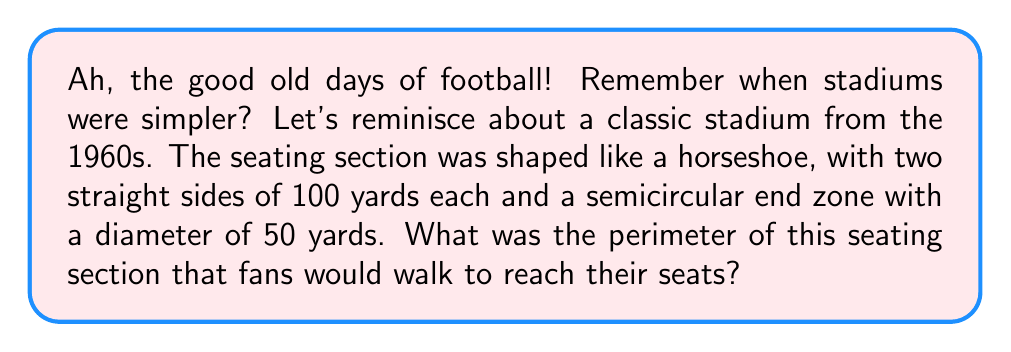Help me with this question. Let's break this down step-by-step, just like we'd analyze a classic play:

1) First, we need to identify the parts of our stadium:
   - Two straight sides, each 100 yards long
   - A semicircular end zone with a diameter of 50 yards

2) The straight sides are easy. We just add them together:
   $$ 100 \text{ yards} + 100 \text{ yards} = 200 \text{ yards} $$

3) Now for the semicircle. Remember, the circumference of a full circle is $\pi d$, where $d$ is the diameter. We only have half a circle, so we'll use half of this formula:
   $$ \text{Length of semicircle} = \frac{1}{2} \pi d = \frac{1}{2} \pi (50 \text{ yards}) $$

4) Let's calculate this:
   $$ \frac{1}{2} \pi (50 \text{ yards}) = 25\pi \text{ yards} \approx 78.54 \text{ yards} $$

5) Now, we add all parts together:
   $$ \text{Total perimeter} = 200 \text{ yards} + 78.54 \text{ yards} = 278.54 \text{ yards} $$

6) Rounding to the nearest yard (as it's more practical for this context):
   $$ \text{Perimeter} \approx 279 \text{ yards} $$

[asy]
unitsize(1cm);
draw((0,0)--(10,0)--(10,5)--(0,5)--cycle);
draw(arc((5,5),2.5,180,360));
label("100 yards", (5,-0.5));
label("50 yards", (5,5.5));
label("100 yards", (10.5,2.5), E);
[/asy]
Answer: The perimeter of the stadium's seating section is approximately 279 yards. 